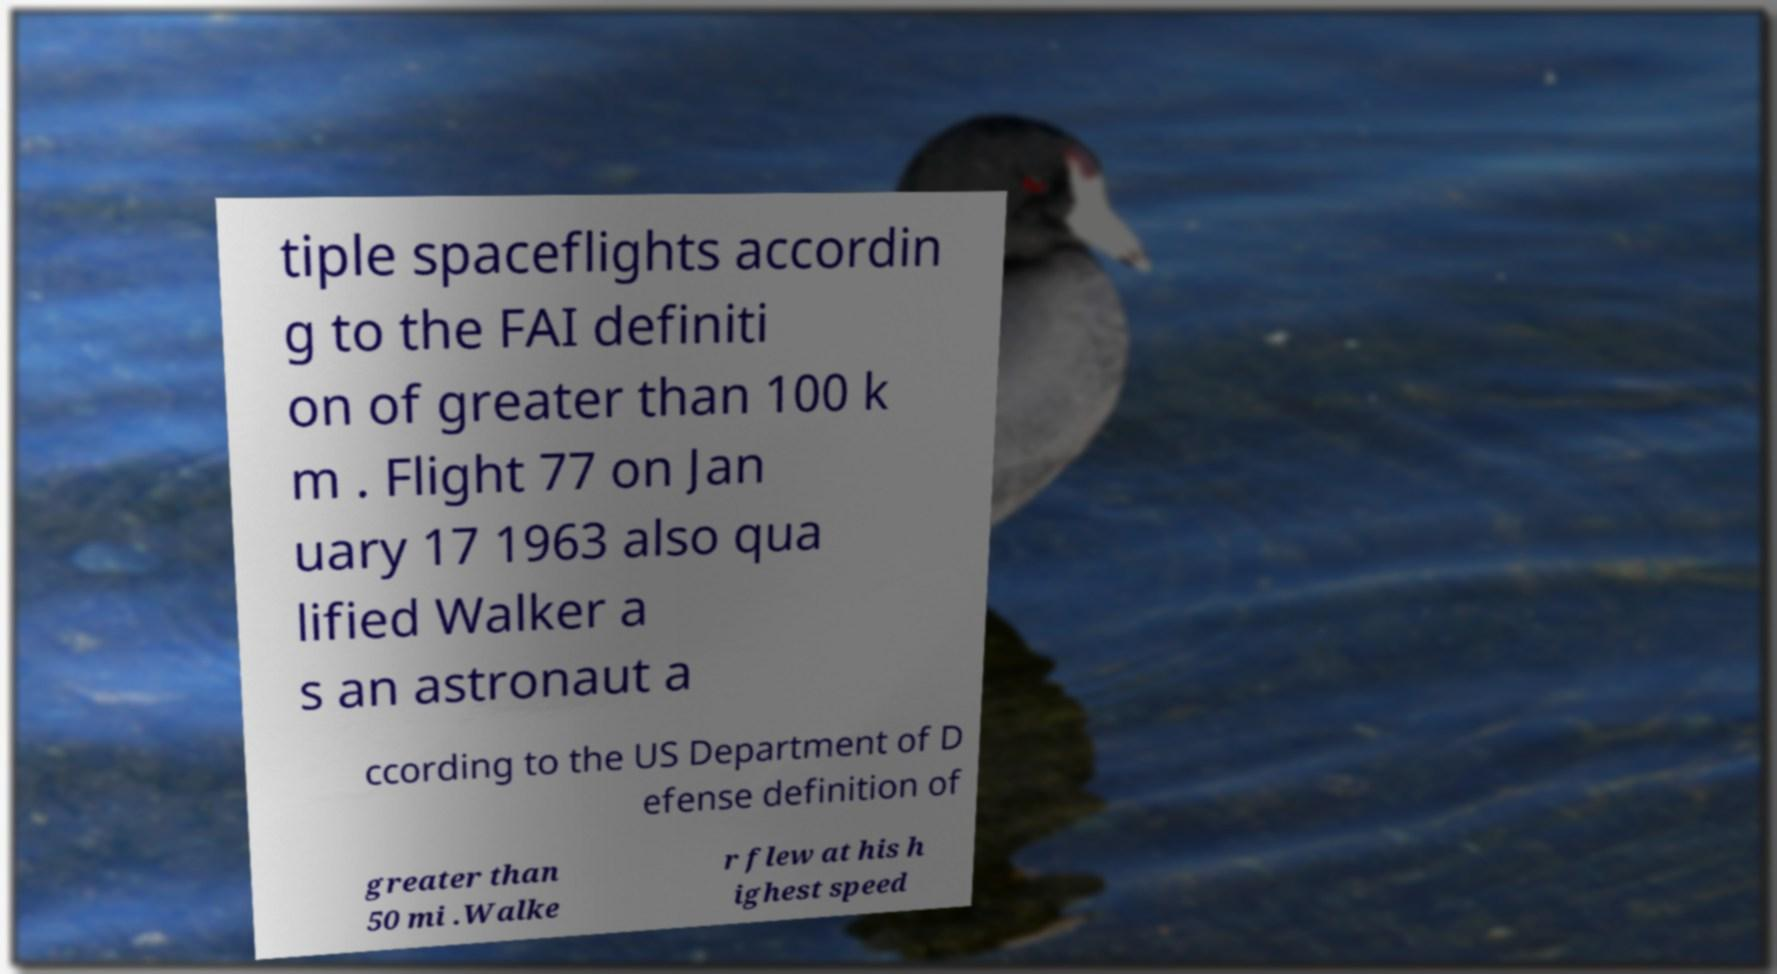Could you extract and type out the text from this image? tiple spaceflights accordin g to the FAI definiti on of greater than 100 k m . Flight 77 on Jan uary 17 1963 also qua lified Walker a s an astronaut a ccording to the US Department of D efense definition of greater than 50 mi .Walke r flew at his h ighest speed 